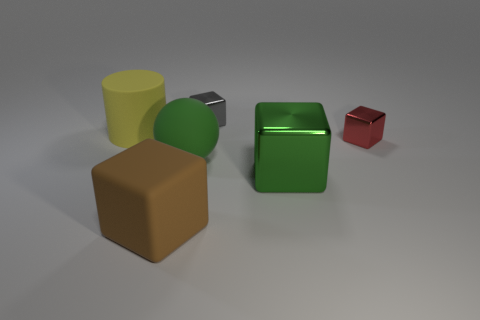Subtract all big brown matte blocks. How many blocks are left? 3 Subtract 4 cubes. How many cubes are left? 0 Add 2 small metallic objects. How many objects exist? 8 Subtract all brown cubes. How many cubes are left? 3 Subtract 0 red balls. How many objects are left? 6 Subtract all cubes. How many objects are left? 2 Subtract all red blocks. Subtract all yellow balls. How many blocks are left? 3 Subtract all cyan spheres. How many yellow blocks are left? 0 Subtract all green matte spheres. Subtract all brown matte cubes. How many objects are left? 4 Add 6 gray things. How many gray things are left? 7 